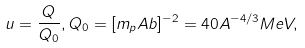<formula> <loc_0><loc_0><loc_500><loc_500>u = \frac { Q } { Q _ { 0 } } , Q _ { 0 } = [ m _ { p } A b ] ^ { - 2 } = 4 0 A ^ { - 4 / 3 } M e V ,</formula> 